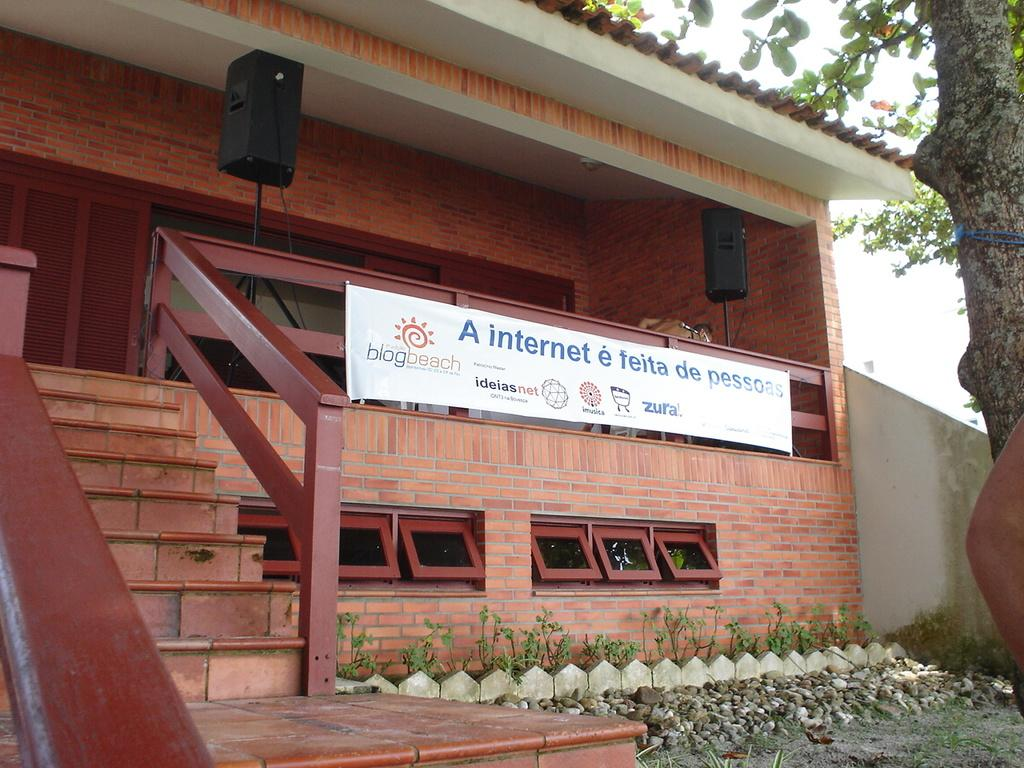What type of structure is visible in the image? There is a house in the image. What architectural feature can be seen in the house? There are stairs in the image. What natural elements are present in the image? There are stones, plants, and a tree in the image. What additional objects can be seen in the image? There is a banner and a sound box in the image. Can you see a rifle being used to blow up the box in the image? There is no box or rifle present in the image, and no action of blowing up is depicted. 